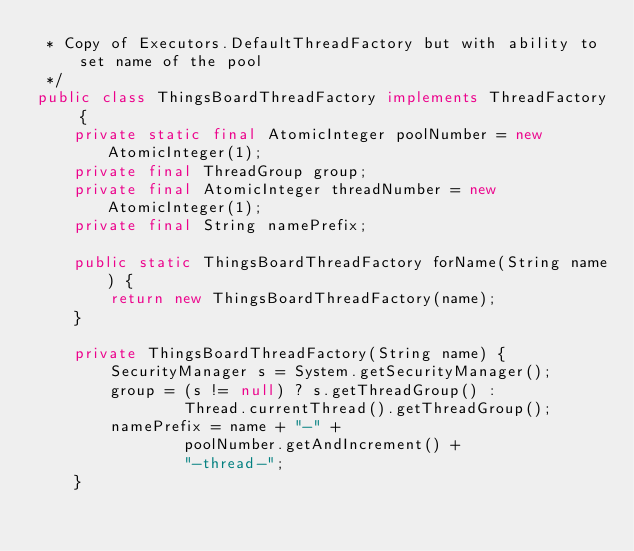<code> <loc_0><loc_0><loc_500><loc_500><_Java_> * Copy of Executors.DefaultThreadFactory but with ability to set name of the pool
 */
public class ThingsBoardThreadFactory implements ThreadFactory {
    private static final AtomicInteger poolNumber = new AtomicInteger(1);
    private final ThreadGroup group;
    private final AtomicInteger threadNumber = new AtomicInteger(1);
    private final String namePrefix;

    public static ThingsBoardThreadFactory forName(String name) {
        return new ThingsBoardThreadFactory(name);
    }

    private ThingsBoardThreadFactory(String name) {
        SecurityManager s = System.getSecurityManager();
        group = (s != null) ? s.getThreadGroup() :
                Thread.currentThread().getThreadGroup();
        namePrefix = name + "-" +
                poolNumber.getAndIncrement() +
                "-thread-";
    }
</code> 